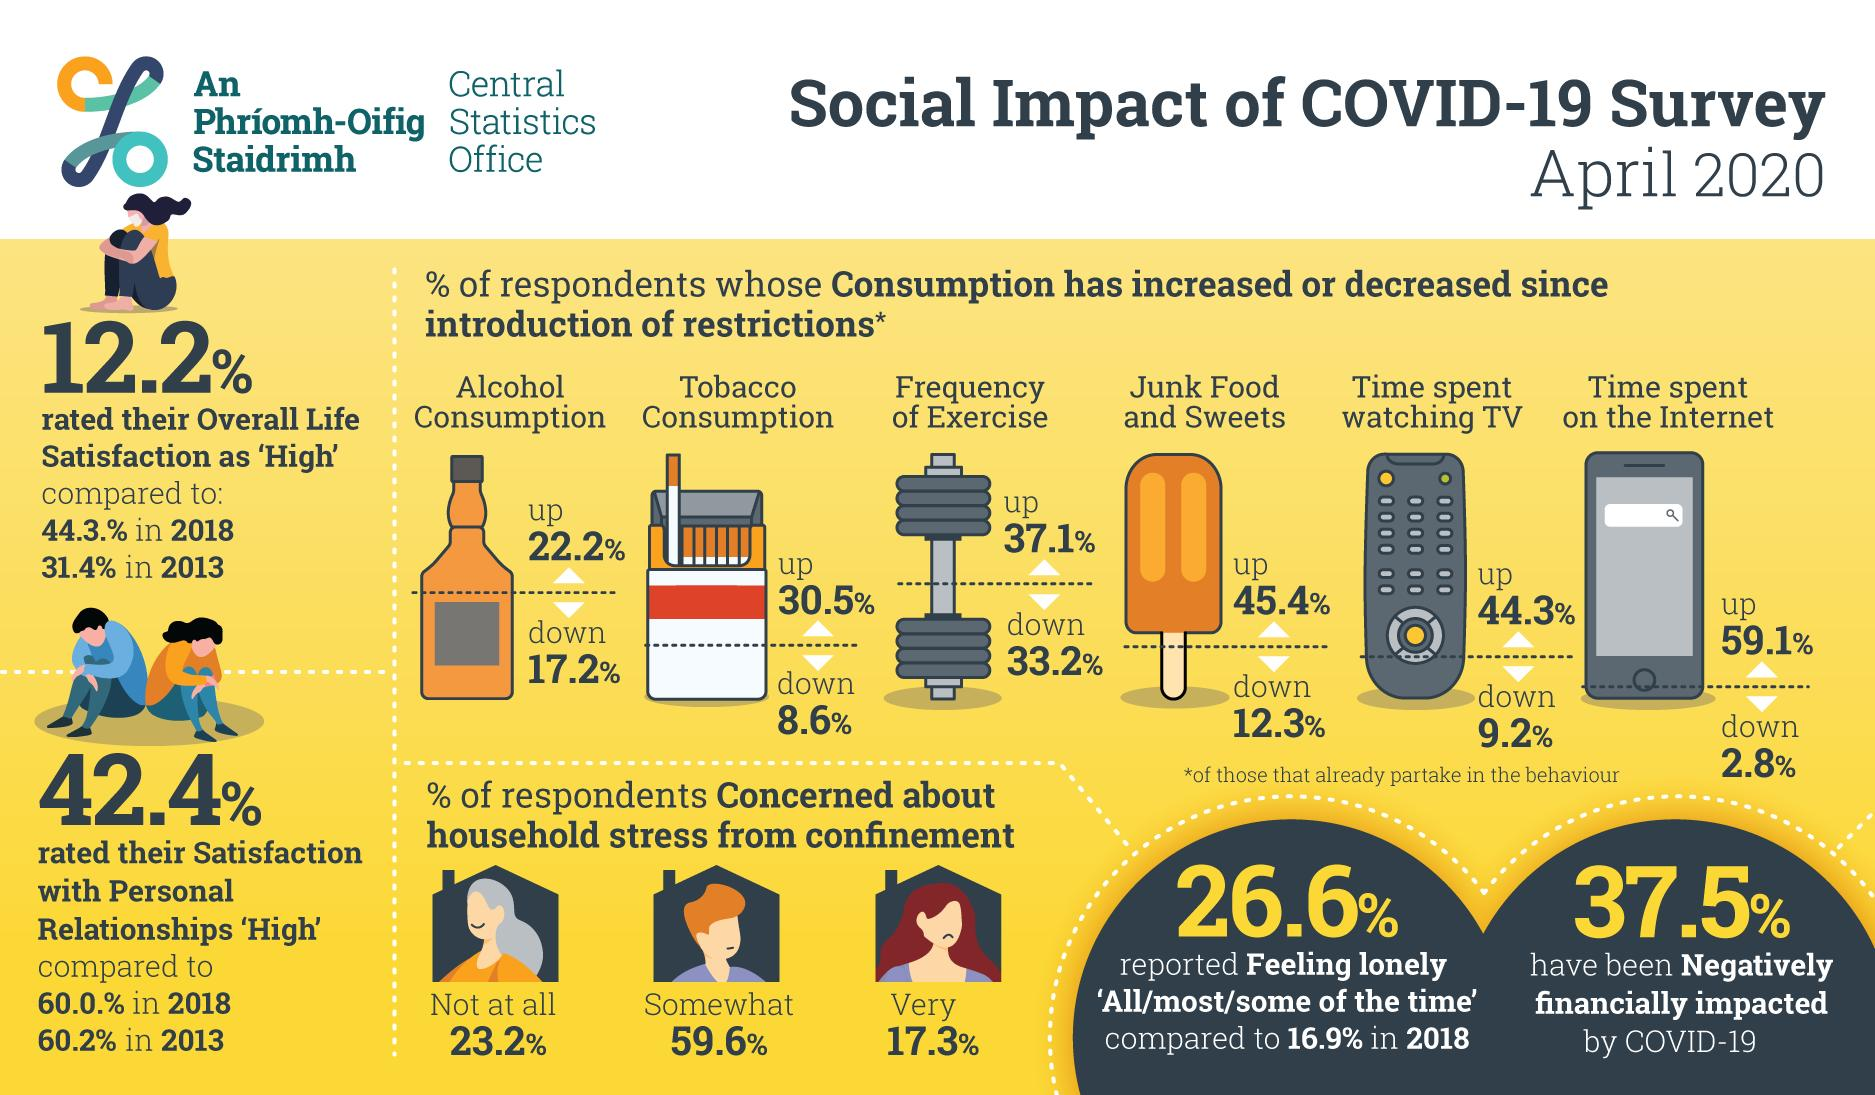Outline some significant characteristics in this image. According to the data, 9.2% of respondents have reported a decrease in the amount of time they spend watching TV since restrictions were introduced. According to the survey conducted in April 2020, 23.2% of respondents expressed zero concern about the household stress caused by confinement due to the impact of COVID-19. In the study, 30.5% of respondents reported an increase in tobacco consumption since the introduction of restrictions. According to the results, 37.1% of respondents reported an increase in the frequency of exercise since the introduction of restrictions. According to a survey conducted in April 2020, 17.3% of respondents reported being very concerned about the impact of COVID-19 on their household stress during confinement. 